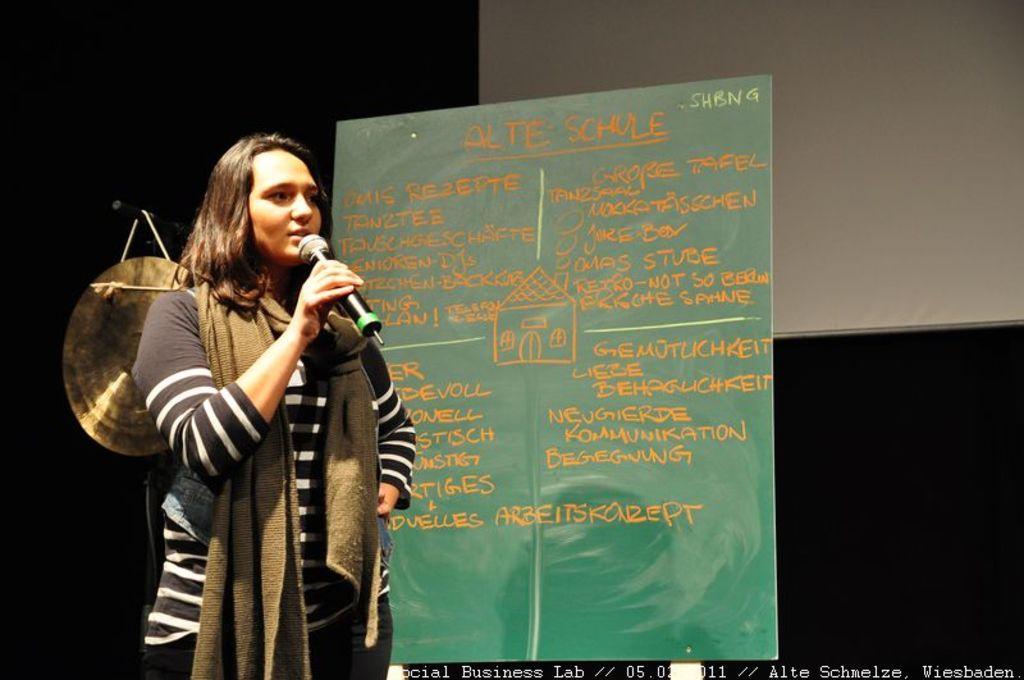Describe this image in one or two sentences. In this image I can see a person standing and holding mic. She is wearing black and white top. Back I can see a green color board and something is writing on it. I can see a screen and black background. 